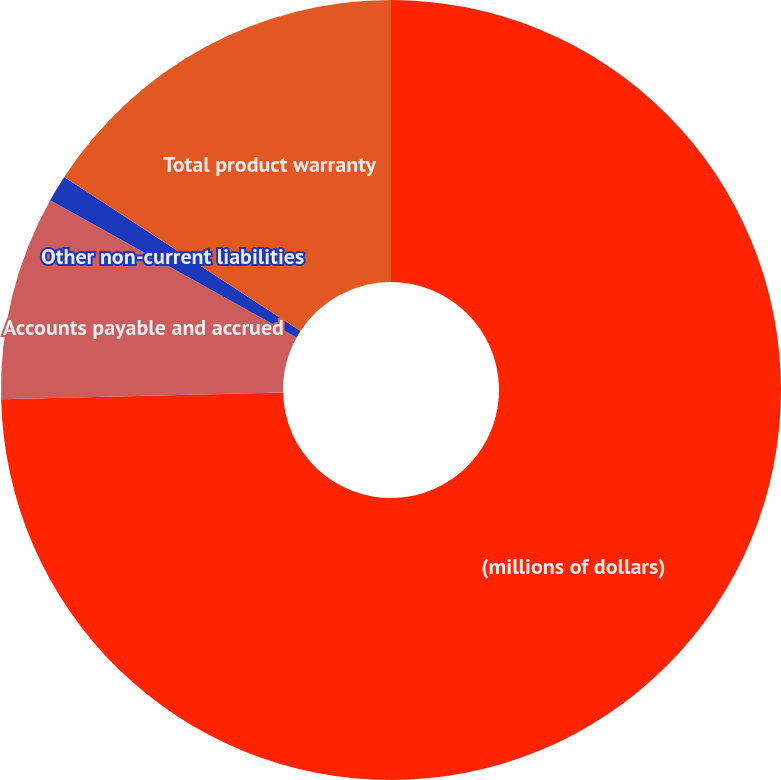Convert chart to OTSL. <chart><loc_0><loc_0><loc_500><loc_500><pie_chart><fcel>(millions of dollars)<fcel>Accounts payable and accrued<fcel>Other non-current liabilities<fcel>Total product warranty<nl><fcel>74.63%<fcel>8.46%<fcel>1.11%<fcel>15.81%<nl></chart> 